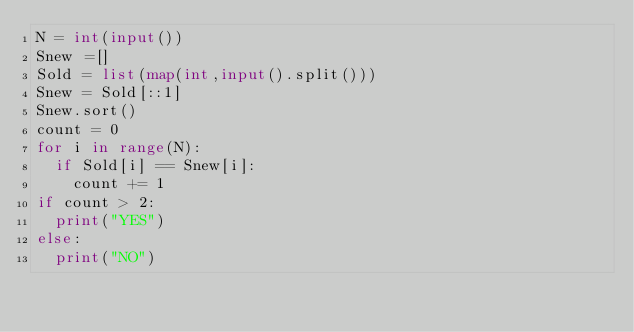<code> <loc_0><loc_0><loc_500><loc_500><_Python_>N = int(input())
Snew =[]
Sold = list(map(int,input().split()))
Snew = Sold[::1]
Snew.sort()
count = 0
for i in range(N):
  if Sold[i] == Snew[i]:
    count += 1
if count > 2:
  print("YES")
else:
  print("NO")</code> 